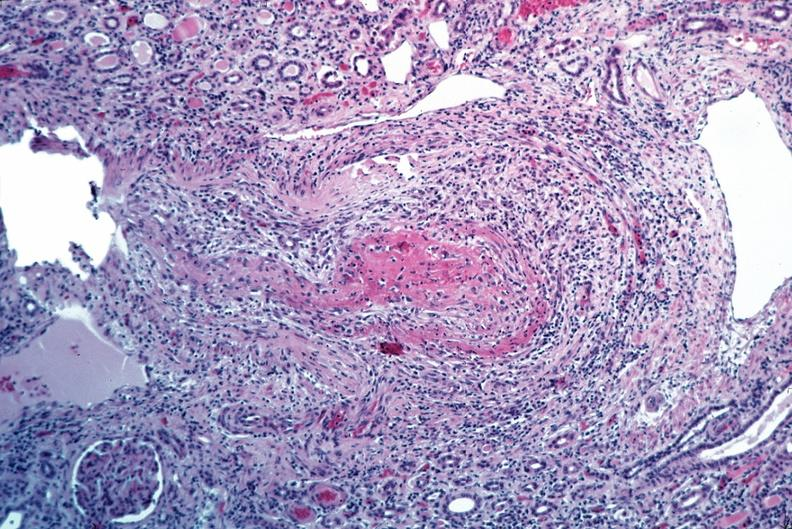does this section showing liver with tumor mass in hilar area tumor show vasculitis, polyarteritis nodosa?
Answer the question using a single word or phrase. No 